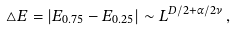<formula> <loc_0><loc_0><loc_500><loc_500>\triangle E = \left | E _ { 0 . 7 5 } - E _ { 0 . 2 5 } \right | \sim L ^ { D / 2 + \alpha / 2 \nu } \, ,</formula> 